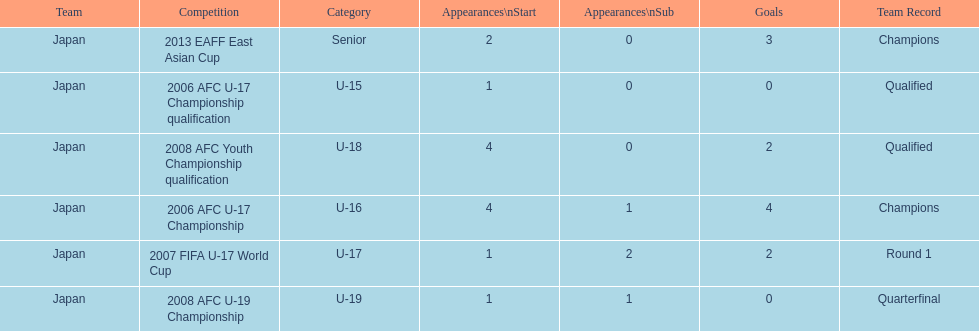What was yoichiro kakitani's first major competition? 2006 AFC U-17 Championship qualification. 